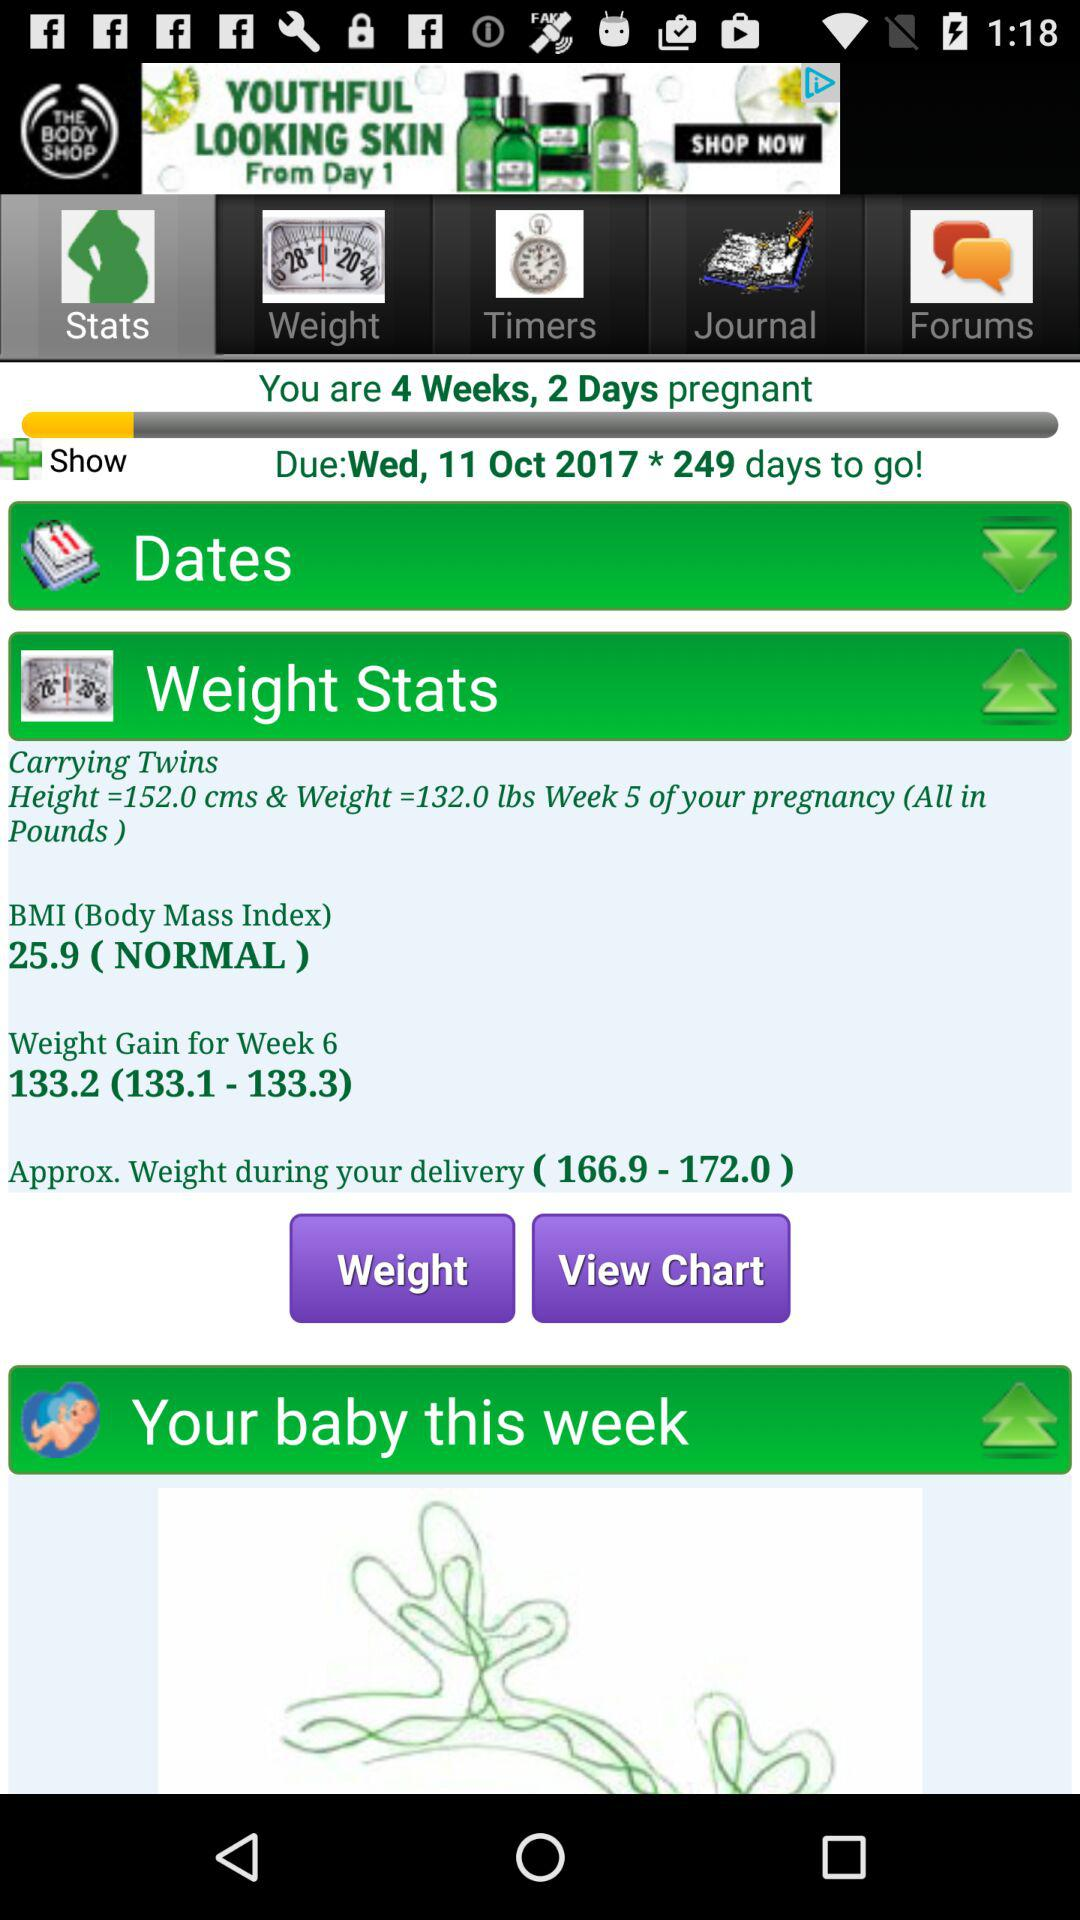How much weight is expected in week 6? The expected weight is between 133.1 and 133.3. 